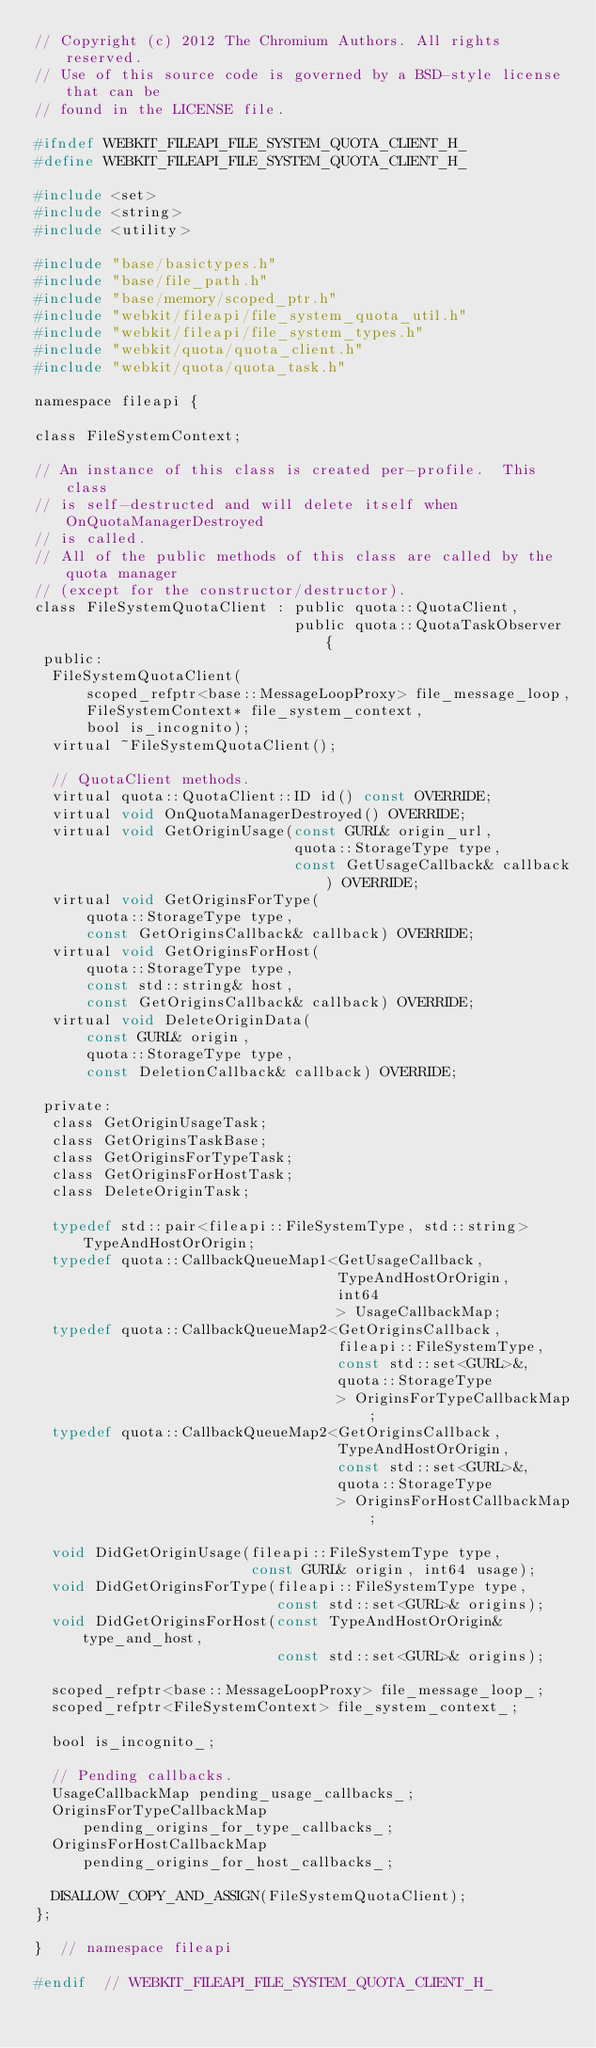<code> <loc_0><loc_0><loc_500><loc_500><_C_>// Copyright (c) 2012 The Chromium Authors. All rights reserved.
// Use of this source code is governed by a BSD-style license that can be
// found in the LICENSE file.

#ifndef WEBKIT_FILEAPI_FILE_SYSTEM_QUOTA_CLIENT_H_
#define WEBKIT_FILEAPI_FILE_SYSTEM_QUOTA_CLIENT_H_

#include <set>
#include <string>
#include <utility>

#include "base/basictypes.h"
#include "base/file_path.h"
#include "base/memory/scoped_ptr.h"
#include "webkit/fileapi/file_system_quota_util.h"
#include "webkit/fileapi/file_system_types.h"
#include "webkit/quota/quota_client.h"
#include "webkit/quota/quota_task.h"

namespace fileapi {

class FileSystemContext;

// An instance of this class is created per-profile.  This class
// is self-destructed and will delete itself when OnQuotaManagerDestroyed
// is called.
// All of the public methods of this class are called by the quota manager
// (except for the constructor/destructor).
class FileSystemQuotaClient : public quota::QuotaClient,
                              public quota::QuotaTaskObserver {
 public:
  FileSystemQuotaClient(
      scoped_refptr<base::MessageLoopProxy> file_message_loop,
      FileSystemContext* file_system_context,
      bool is_incognito);
  virtual ~FileSystemQuotaClient();

  // QuotaClient methods.
  virtual quota::QuotaClient::ID id() const OVERRIDE;
  virtual void OnQuotaManagerDestroyed() OVERRIDE;
  virtual void GetOriginUsage(const GURL& origin_url,
                              quota::StorageType type,
                              const GetUsageCallback& callback) OVERRIDE;
  virtual void GetOriginsForType(
      quota::StorageType type,
      const GetOriginsCallback& callback) OVERRIDE;
  virtual void GetOriginsForHost(
      quota::StorageType type,
      const std::string& host,
      const GetOriginsCallback& callback) OVERRIDE;
  virtual void DeleteOriginData(
      const GURL& origin,
      quota::StorageType type,
      const DeletionCallback& callback) OVERRIDE;

 private:
  class GetOriginUsageTask;
  class GetOriginsTaskBase;
  class GetOriginsForTypeTask;
  class GetOriginsForHostTask;
  class DeleteOriginTask;

  typedef std::pair<fileapi::FileSystemType, std::string> TypeAndHostOrOrigin;
  typedef quota::CallbackQueueMap1<GetUsageCallback,
                                   TypeAndHostOrOrigin,
                                   int64
                                   > UsageCallbackMap;
  typedef quota::CallbackQueueMap2<GetOriginsCallback,
                                   fileapi::FileSystemType,
                                   const std::set<GURL>&,
                                   quota::StorageType
                                   > OriginsForTypeCallbackMap;
  typedef quota::CallbackQueueMap2<GetOriginsCallback,
                                   TypeAndHostOrOrigin,
                                   const std::set<GURL>&,
                                   quota::StorageType
                                   > OriginsForHostCallbackMap;

  void DidGetOriginUsage(fileapi::FileSystemType type,
                         const GURL& origin, int64 usage);
  void DidGetOriginsForType(fileapi::FileSystemType type,
                            const std::set<GURL>& origins);
  void DidGetOriginsForHost(const TypeAndHostOrOrigin& type_and_host,
                            const std::set<GURL>& origins);

  scoped_refptr<base::MessageLoopProxy> file_message_loop_;
  scoped_refptr<FileSystemContext> file_system_context_;

  bool is_incognito_;

  // Pending callbacks.
  UsageCallbackMap pending_usage_callbacks_;
  OriginsForTypeCallbackMap pending_origins_for_type_callbacks_;
  OriginsForHostCallbackMap pending_origins_for_host_callbacks_;

  DISALLOW_COPY_AND_ASSIGN(FileSystemQuotaClient);
};

}  // namespace fileapi

#endif  // WEBKIT_FILEAPI_FILE_SYSTEM_QUOTA_CLIENT_H_
</code> 